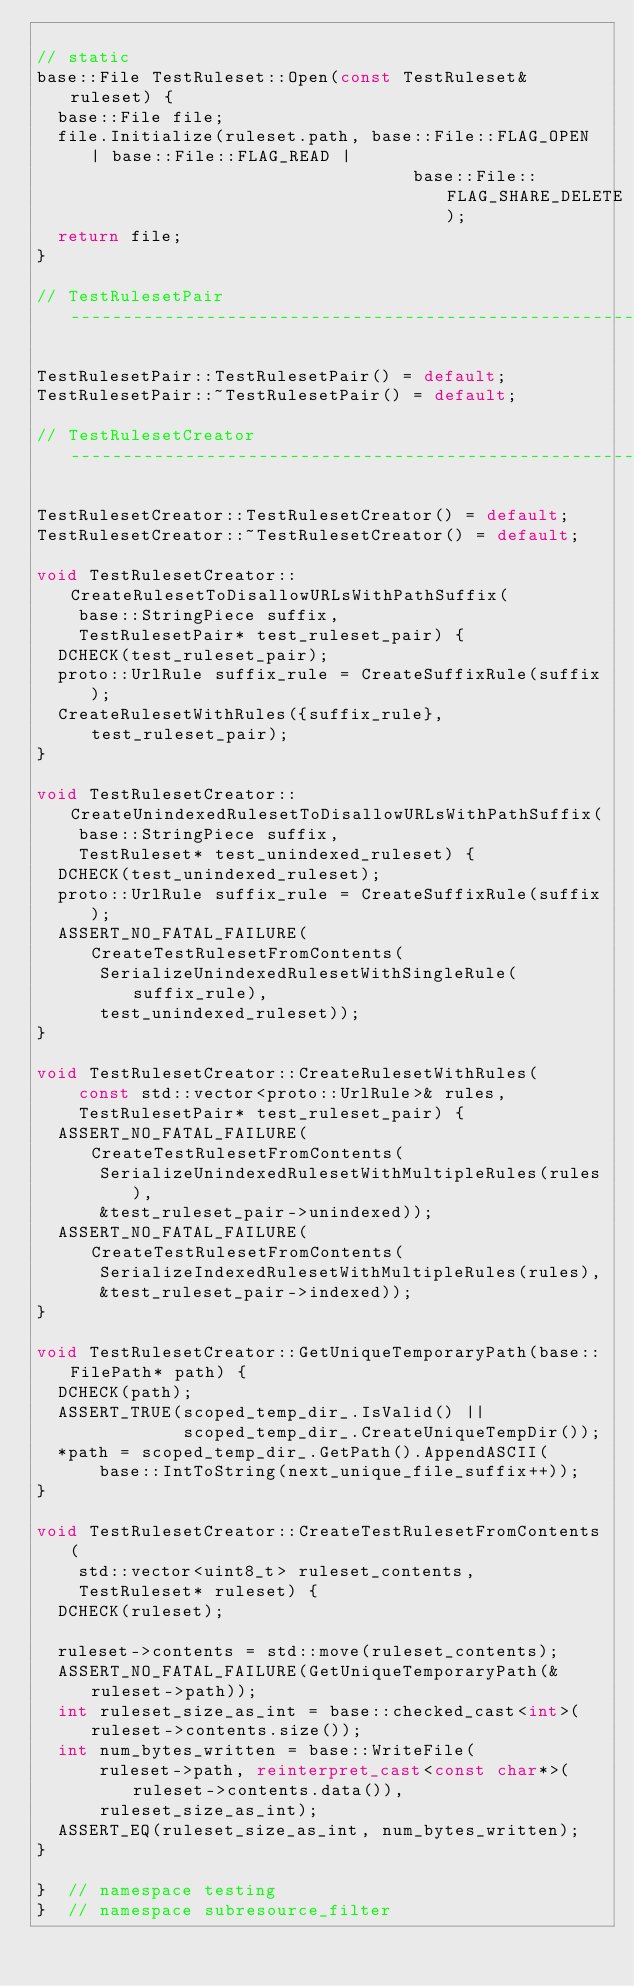<code> <loc_0><loc_0><loc_500><loc_500><_C++_>
// static
base::File TestRuleset::Open(const TestRuleset& ruleset) {
  base::File file;
  file.Initialize(ruleset.path, base::File::FLAG_OPEN | base::File::FLAG_READ |
                                    base::File::FLAG_SHARE_DELETE);
  return file;
}

// TestRulesetPair -------------------------------------------------------------

TestRulesetPair::TestRulesetPair() = default;
TestRulesetPair::~TestRulesetPair() = default;

// TestRulesetCreator ----------------------------------------------------------

TestRulesetCreator::TestRulesetCreator() = default;
TestRulesetCreator::~TestRulesetCreator() = default;

void TestRulesetCreator::CreateRulesetToDisallowURLsWithPathSuffix(
    base::StringPiece suffix,
    TestRulesetPair* test_ruleset_pair) {
  DCHECK(test_ruleset_pair);
  proto::UrlRule suffix_rule = CreateSuffixRule(suffix);
  CreateRulesetWithRules({suffix_rule}, test_ruleset_pair);
}

void TestRulesetCreator::CreateUnindexedRulesetToDisallowURLsWithPathSuffix(
    base::StringPiece suffix,
    TestRuleset* test_unindexed_ruleset) {
  DCHECK(test_unindexed_ruleset);
  proto::UrlRule suffix_rule = CreateSuffixRule(suffix);
  ASSERT_NO_FATAL_FAILURE(CreateTestRulesetFromContents(
      SerializeUnindexedRulesetWithSingleRule(suffix_rule),
      test_unindexed_ruleset));
}

void TestRulesetCreator::CreateRulesetWithRules(
    const std::vector<proto::UrlRule>& rules,
    TestRulesetPair* test_ruleset_pair) {
  ASSERT_NO_FATAL_FAILURE(CreateTestRulesetFromContents(
      SerializeUnindexedRulesetWithMultipleRules(rules),
      &test_ruleset_pair->unindexed));
  ASSERT_NO_FATAL_FAILURE(CreateTestRulesetFromContents(
      SerializeIndexedRulesetWithMultipleRules(rules),
      &test_ruleset_pair->indexed));
}

void TestRulesetCreator::GetUniqueTemporaryPath(base::FilePath* path) {
  DCHECK(path);
  ASSERT_TRUE(scoped_temp_dir_.IsValid() ||
              scoped_temp_dir_.CreateUniqueTempDir());
  *path = scoped_temp_dir_.GetPath().AppendASCII(
      base::IntToString(next_unique_file_suffix++));
}

void TestRulesetCreator::CreateTestRulesetFromContents(
    std::vector<uint8_t> ruleset_contents,
    TestRuleset* ruleset) {
  DCHECK(ruleset);

  ruleset->contents = std::move(ruleset_contents);
  ASSERT_NO_FATAL_FAILURE(GetUniqueTemporaryPath(&ruleset->path));
  int ruleset_size_as_int = base::checked_cast<int>(ruleset->contents.size());
  int num_bytes_written = base::WriteFile(
      ruleset->path, reinterpret_cast<const char*>(ruleset->contents.data()),
      ruleset_size_as_int);
  ASSERT_EQ(ruleset_size_as_int, num_bytes_written);
}

}  // namespace testing
}  // namespace subresource_filter
</code> 